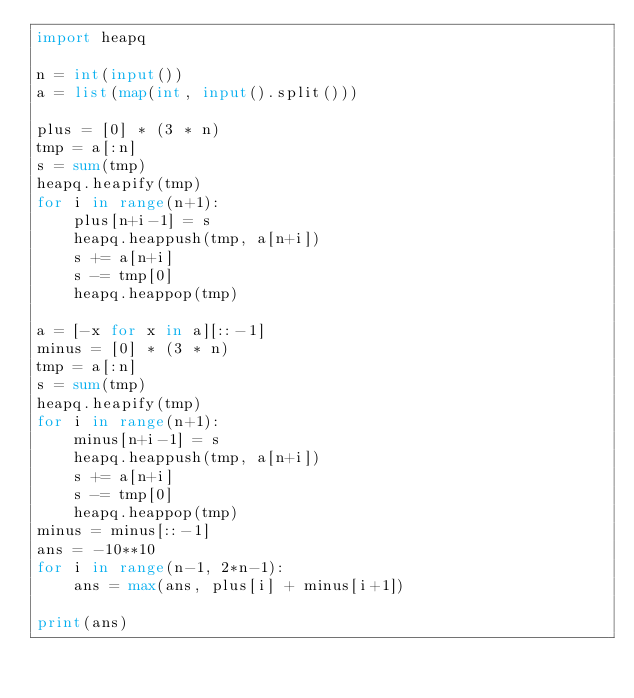<code> <loc_0><loc_0><loc_500><loc_500><_Python_>import heapq

n = int(input())
a = list(map(int, input().split()))

plus = [0] * (3 * n)
tmp = a[:n]
s = sum(tmp)
heapq.heapify(tmp)
for i in range(n+1):
    plus[n+i-1] = s
    heapq.heappush(tmp, a[n+i])
    s += a[n+i]
    s -= tmp[0]
    heapq.heappop(tmp)

a = [-x for x in a][::-1]
minus = [0] * (3 * n)
tmp = a[:n]
s = sum(tmp)
heapq.heapify(tmp)
for i in range(n+1):
    minus[n+i-1] = s
    heapq.heappush(tmp, a[n+i])
    s += a[n+i]
    s -= tmp[0]
    heapq.heappop(tmp)
minus = minus[::-1]
ans = -10**10
for i in range(n-1, 2*n-1):
    ans = max(ans, plus[i] + minus[i+1])

print(ans)</code> 